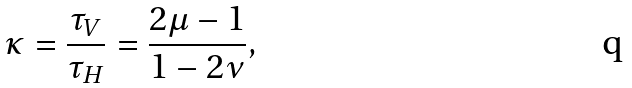Convert formula to latex. <formula><loc_0><loc_0><loc_500><loc_500>\kappa = \frac { \tau _ { V } } { \tau _ { H } } = { \frac { 2 \mu - 1 } { 1 - 2 \nu } } ,</formula> 